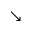Convert formula to latex. <formula><loc_0><loc_0><loc_500><loc_500>\searrow</formula> 